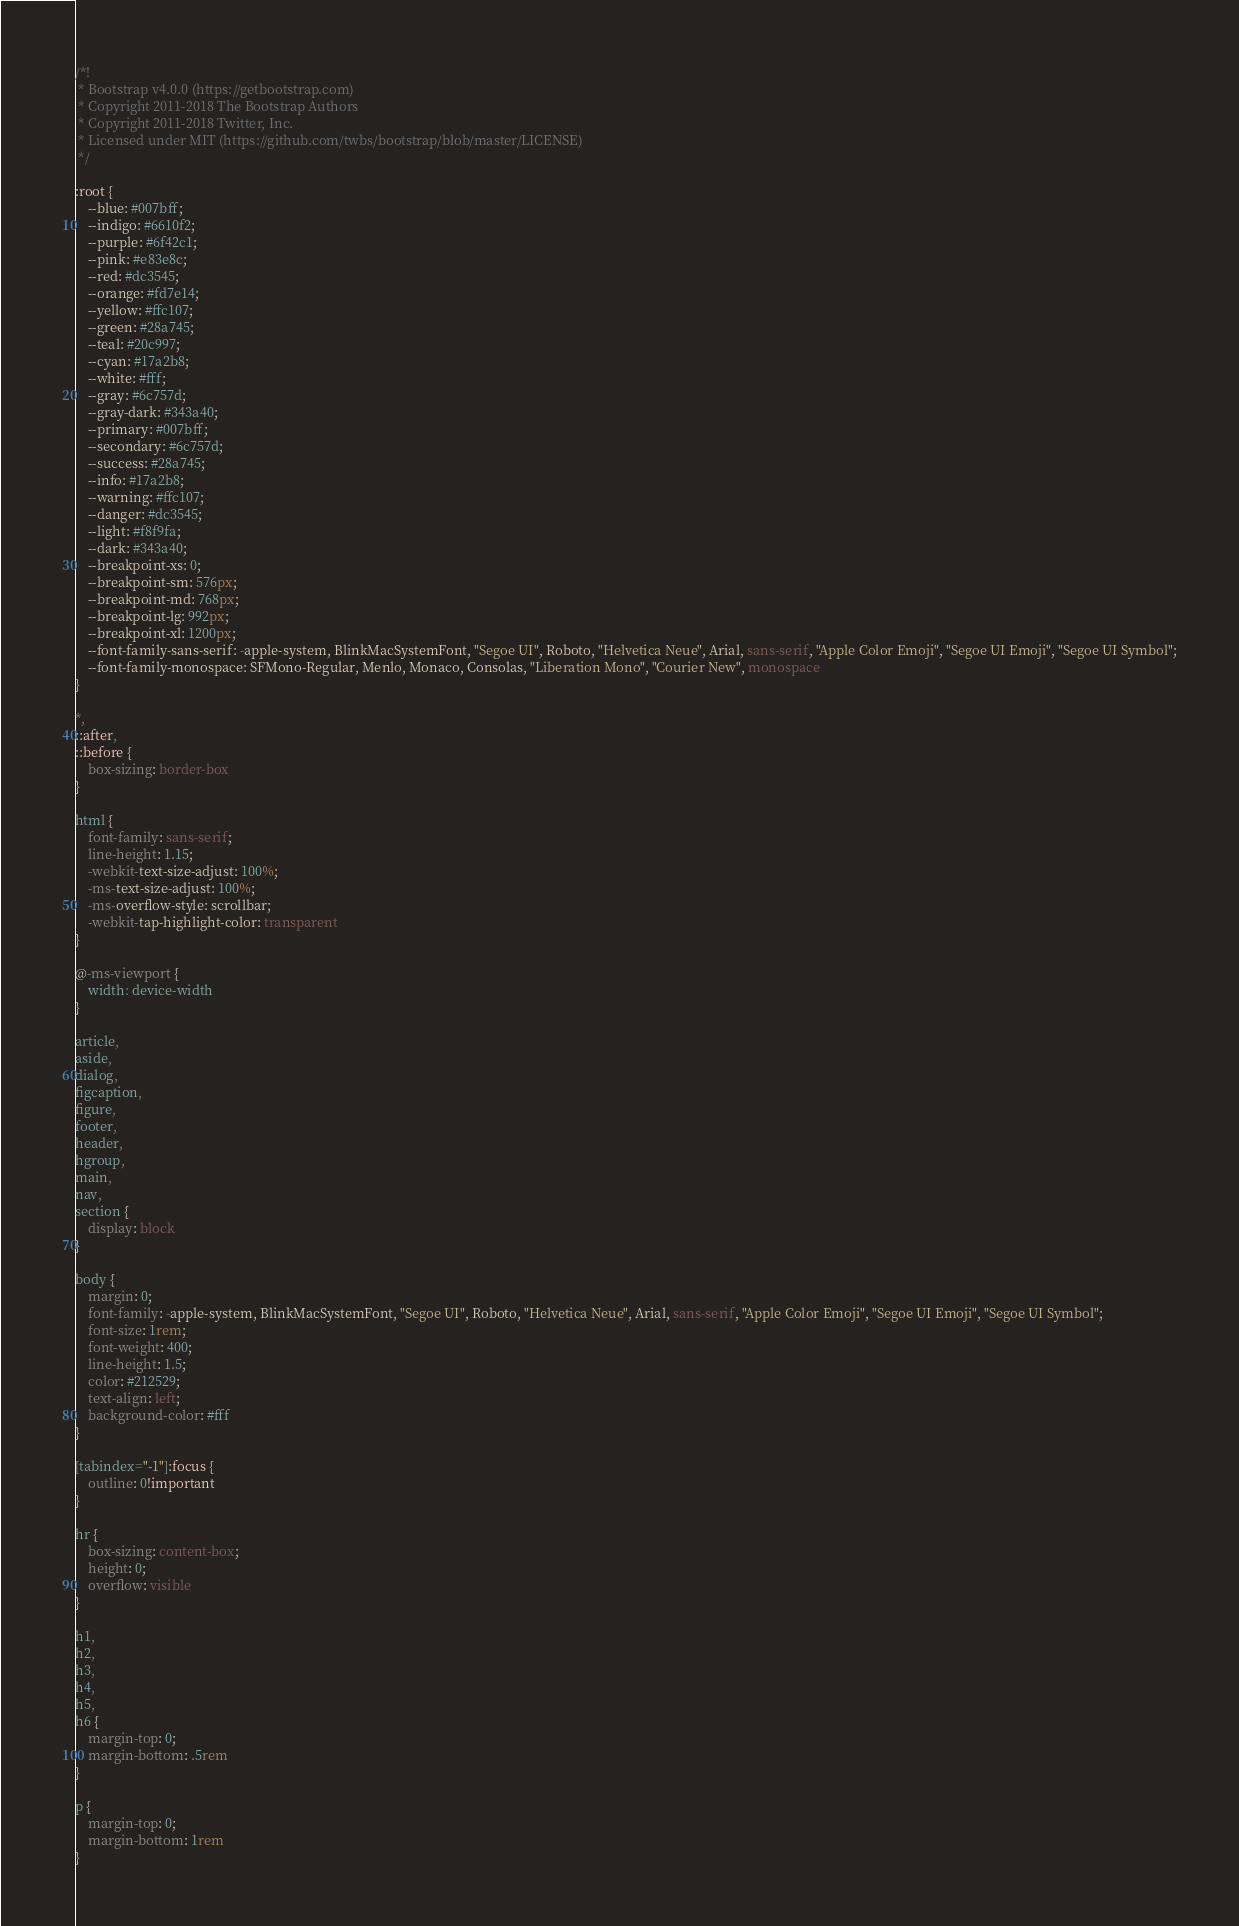<code> <loc_0><loc_0><loc_500><loc_500><_CSS_>/*!
 * Bootstrap v4.0.0 (https://getbootstrap.com)
 * Copyright 2011-2018 The Bootstrap Authors
 * Copyright 2011-2018 Twitter, Inc.
 * Licensed under MIT (https://github.com/twbs/bootstrap/blob/master/LICENSE)
 */

:root {
    --blue: #007bff;
    --indigo: #6610f2;
    --purple: #6f42c1;
    --pink: #e83e8c;
    --red: #dc3545;
    --orange: #fd7e14;
    --yellow: #ffc107;
    --green: #28a745;
    --teal: #20c997;
    --cyan: #17a2b8;
    --white: #fff;
    --gray: #6c757d;
    --gray-dark: #343a40;
    --primary: #007bff;
    --secondary: #6c757d;
    --success: #28a745;
    --info: #17a2b8;
    --warning: #ffc107;
    --danger: #dc3545;
    --light: #f8f9fa;
    --dark: #343a40;
    --breakpoint-xs: 0;
    --breakpoint-sm: 576px;
    --breakpoint-md: 768px;
    --breakpoint-lg: 992px;
    --breakpoint-xl: 1200px;
    --font-family-sans-serif: -apple-system, BlinkMacSystemFont, "Segoe UI", Roboto, "Helvetica Neue", Arial, sans-serif, "Apple Color Emoji", "Segoe UI Emoji", "Segoe UI Symbol";
    --font-family-monospace: SFMono-Regular, Menlo, Monaco, Consolas, "Liberation Mono", "Courier New", monospace
}

*,
::after,
::before {
    box-sizing: border-box
}

html {
    font-family: sans-serif;
    line-height: 1.15;
    -webkit-text-size-adjust: 100%;
    -ms-text-size-adjust: 100%;
    -ms-overflow-style: scrollbar;
    -webkit-tap-highlight-color: transparent
}

@-ms-viewport {
    width: device-width
}

article,
aside,
dialog,
figcaption,
figure,
footer,
header,
hgroup,
main,
nav,
section {
    display: block
}

body {
    margin: 0;
    font-family: -apple-system, BlinkMacSystemFont, "Segoe UI", Roboto, "Helvetica Neue", Arial, sans-serif, "Apple Color Emoji", "Segoe UI Emoji", "Segoe UI Symbol";
    font-size: 1rem;
    font-weight: 400;
    line-height: 1.5;
    color: #212529;
    text-align: left;
    background-color: #fff
}

[tabindex="-1"]:focus {
    outline: 0!important
}

hr {
    box-sizing: content-box;
    height: 0;
    overflow: visible
}

h1,
h2,
h3,
h4,
h5,
h6 {
    margin-top: 0;
    margin-bottom: .5rem
}

p {
    margin-top: 0;
    margin-bottom: 1rem
}
</code> 